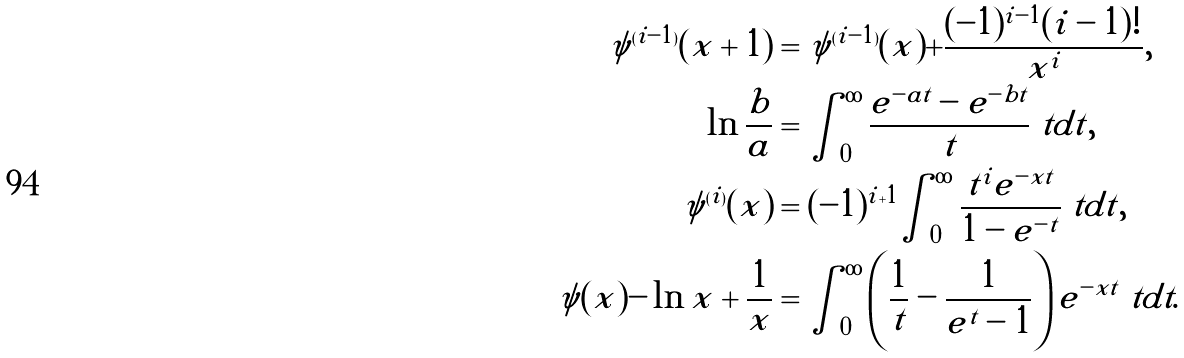<formula> <loc_0><loc_0><loc_500><loc_500>\psi ^ { ( i - 1 ) } ( x + 1 ) & = \psi ^ { ( i - 1 ) } ( x ) + \frac { ( - 1 ) ^ { i - 1 } ( i - 1 ) ! } { x ^ { i } } , \\ \ln \frac { b } a & = \int _ { 0 } ^ { \infty } \frac { e ^ { - a t } - e ^ { - b t } } t \ t d t , \\ \psi ^ { ( i ) } ( x ) & = ( - 1 ) ^ { i + 1 } \int _ { 0 } ^ { \infty } \frac { t ^ { i } e ^ { - x t } } { 1 - e ^ { - t } } \ t d t , \\ \psi ( x ) - \ln x + \frac { 1 } { x } & = \int _ { 0 } ^ { \infty } \left ( \frac { 1 } { t } - \frac { 1 } { e ^ { t } - 1 } \right ) e ^ { - x t } \ t d t .</formula> 